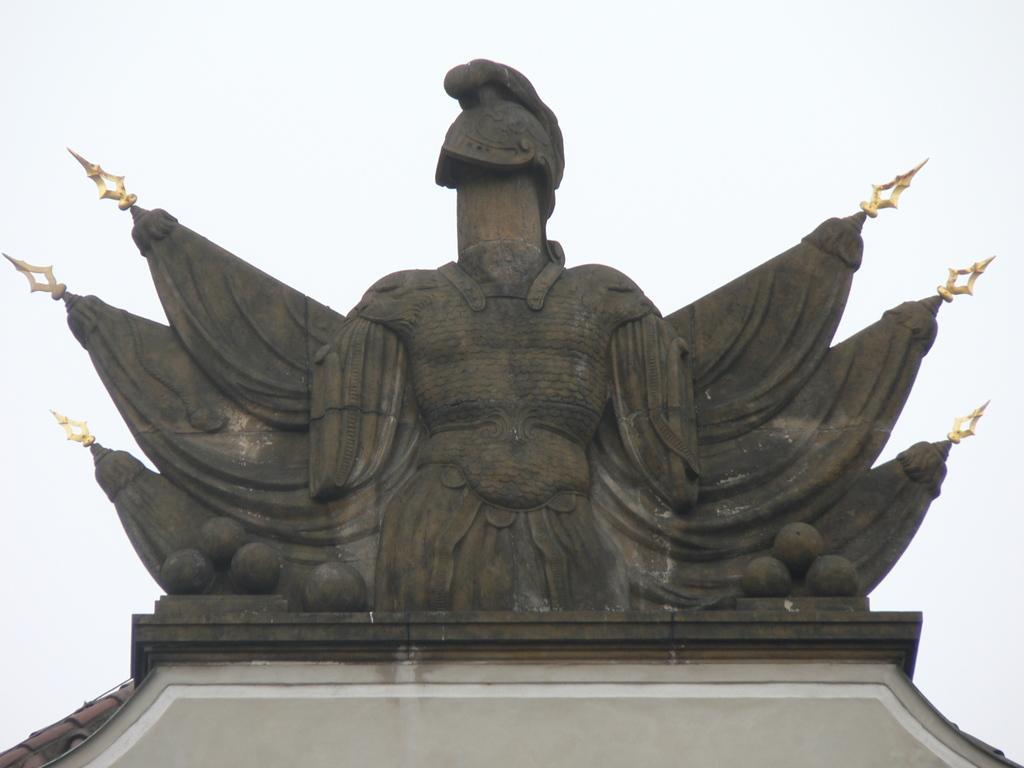In one or two sentences, can you explain what this image depicts? Here in this picture we can see a statue present on a arch over there. 